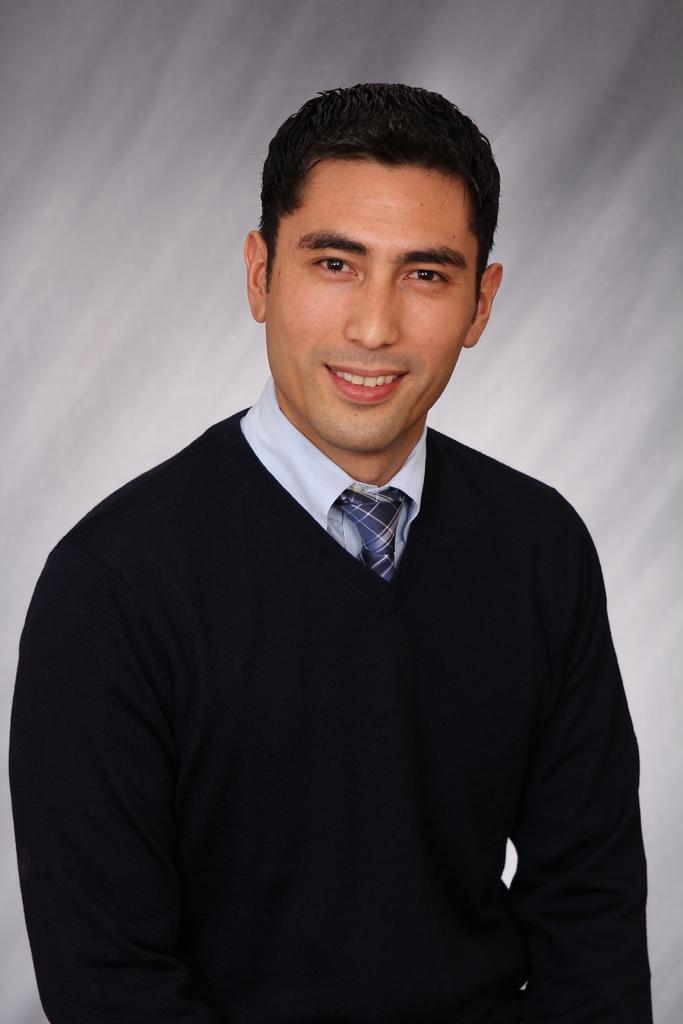Describe this image in one or two sentences. In the foreground of this image, there is man in black colored dress and in blue tie and having smile on his face. There is a white background. 